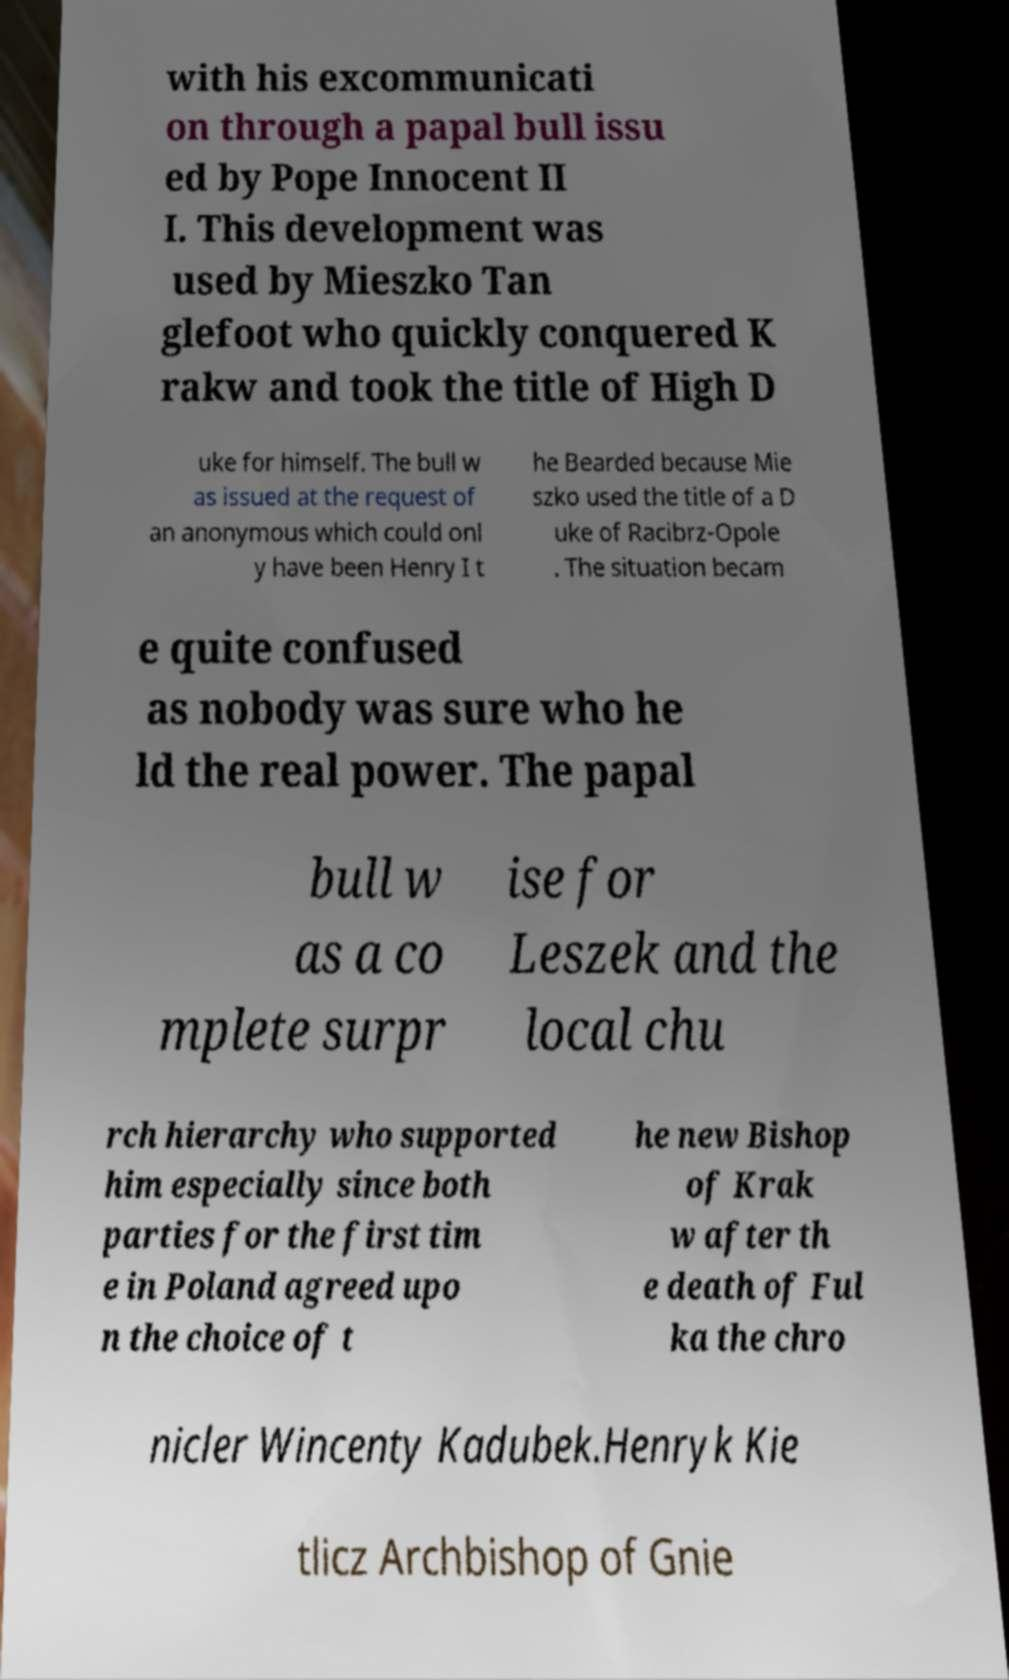What messages or text are displayed in this image? I need them in a readable, typed format. with his excommunicati on through a papal bull issu ed by Pope Innocent II I. This development was used by Mieszko Tan glefoot who quickly conquered K rakw and took the title of High D uke for himself. The bull w as issued at the request of an anonymous which could onl y have been Henry I t he Bearded because Mie szko used the title of a D uke of Racibrz-Opole . The situation becam e quite confused as nobody was sure who he ld the real power. The papal bull w as a co mplete surpr ise for Leszek and the local chu rch hierarchy who supported him especially since both parties for the first tim e in Poland agreed upo n the choice of t he new Bishop of Krak w after th e death of Ful ka the chro nicler Wincenty Kadubek.Henryk Kie tlicz Archbishop of Gnie 